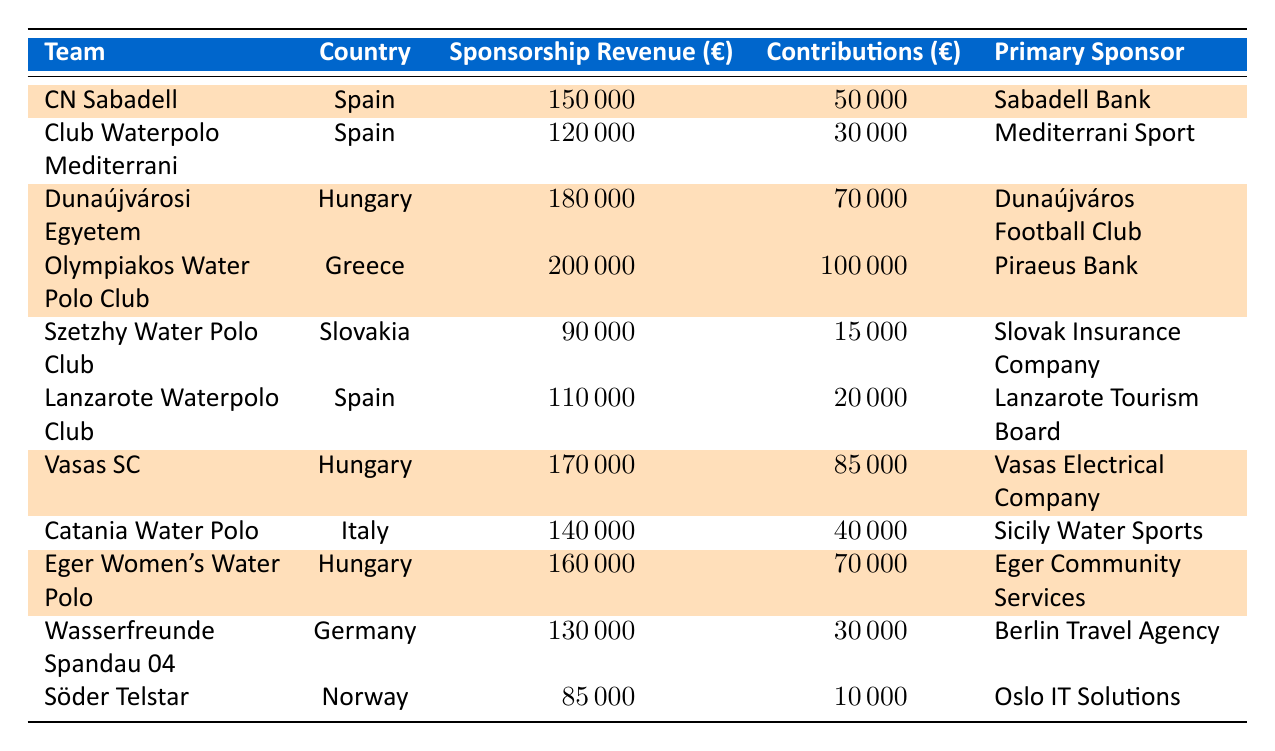What is the primary sponsor for CN Sabadell? The table shows that CN Sabadell has "Sabadell Bank" listed as its primary sponsor.
Answer: Sabadell Bank Which team has the highest sponsorship revenue? By comparing the values in the "Sponsorship Revenue" column, Olympiakos Water Polo Club has the highest amount at €200,000.
Answer: Olympiakos Water Polo Club How much total sponsorship revenue do the highlighted teams have? The highlighted teams are CN Sabadell (€150,000), Dunaújvárosi Egyetem (€180,000), Olympiakos Water Polo Club (€200,000), Vasas SC (€170,000), and Eger Women's Water Polo (€160,000). If we sum these values, we get 150,000 + 180,000 + 200,000 + 170,000 + 160,000 = 1,060,000.
Answer: €1,060,000 Is there any team from Norway in the highlighted section? The table shows that Söder Telstar is from Norway but is not highlighted, confirming that no team from Norway is in the highlighted section.
Answer: No What percentage of total contributions does Olympiakos Water Polo Club receive compared to all teams? Total contributions from all teams equal €50000 + €30000 + €70000 + €100000 + €15000 + €20000 + €85000 + €40000 + €70000 + €30000 + €10000 = €425,000. Olympiakos Water Polo Club's contributions are €100,000. The percentage is calculated as (€100,000 / €425,000) * 100 = 23.53%.
Answer: 23.53% How does the average sponsorship revenue of teams from Hungary compare to teams from Spain? For Hungarian teams, the sponsorship revenues are €180,000 (Dunaújvárosi Egyetem), €170,000 (Vasas SC), and €160,000 (Eger Women's Water Polo), which gives an average of (180,000 + 170,000 + 160,000)/3 = €170,000. For Spanish teams, the revenues are €150,000 (CN Sabadell), €120,000 (Club Waterpolo Mediterrani), and €110,000 (Lanzarote Waterpolo Club), resulting in an average of (150,000 + 120,000 + 110,000)/3 = €126,667. Therefore, Hungarian teams have a higher average sponsorship revenue.
Answer: Hungarian teams have a higher average revenue Which country provides the most teams in the highlighted section? The highlighted teams and their countries are CN Sabadell (Spain), Dunaújvárosi Egyetem (Hungary), Olympiakos Water Polo Club (Greece), Vasas SC (Hungary), and Eger Women's Water Polo (Hungary). Hungary appears three times, making it the country with the most highlighted teams.
Answer: Hungary What is the total contributions for teams based in Spain? The contributions for Spanish teams are €50,000 (CN Sabadell) + €30,000 (Club Waterpolo Mediterrani) + €20,000 (Lanzarote Waterpolo Club). Summing these gives €50,000 + €30,000 + €20,000 = €100,000.
Answer: €100,000 Are there any teams with sponsorship revenues below €100,000? From the table, Szetzhy Water Polo Club has €90,000, and Söder Telstar has €85,000, which confirms that there are indeed teams with sponsorship revenues below €100,000.
Answer: Yes 